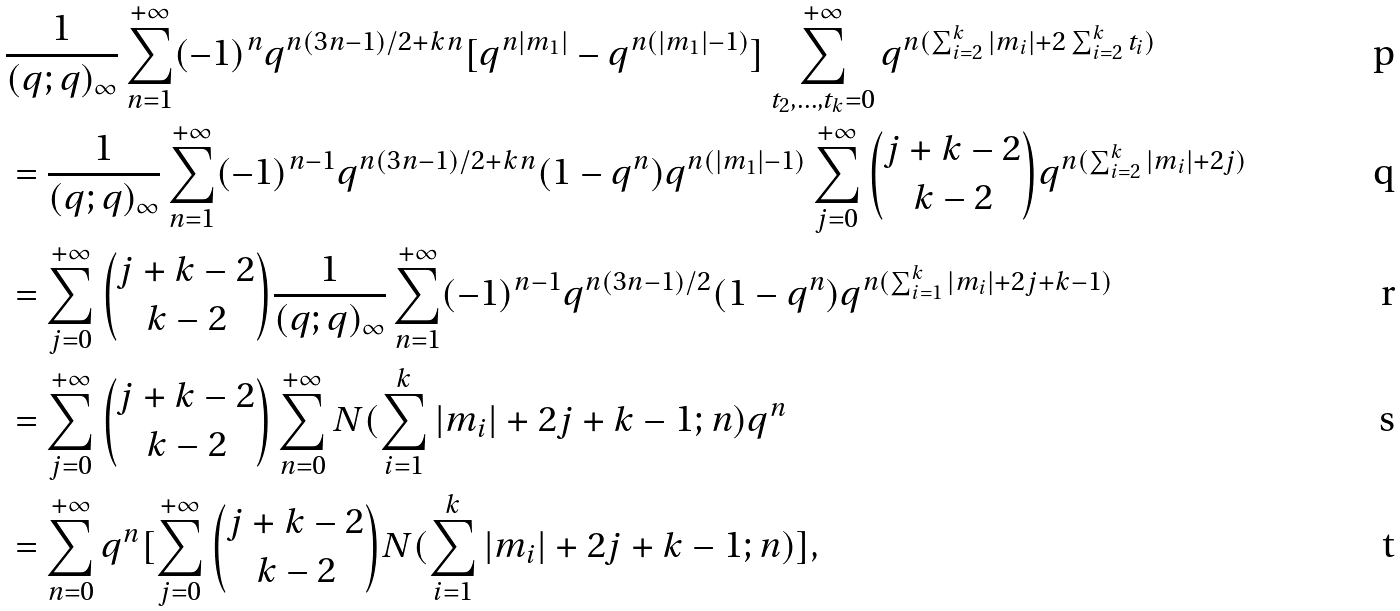<formula> <loc_0><loc_0><loc_500><loc_500>& \frac { 1 } { ( q ; q ) _ { \infty } } \sum _ { n = 1 } ^ { + \infty } ( - 1 ) ^ { n } q ^ { n ( 3 n - 1 ) / 2 + k n } [ q ^ { n | m _ { 1 } | } - q ^ { n ( | m _ { 1 } | - 1 ) } ] \sum _ { t _ { 2 } , \dots , t _ { k } = 0 } ^ { + \infty } q ^ { n ( \sum _ { i = 2 } ^ { k } | m _ { i } | + 2 \sum _ { i = 2 } ^ { k } t _ { i } ) } \\ & = \frac { 1 } { ( q ; q ) _ { \infty } } \sum _ { n = 1 } ^ { + \infty } ( - 1 ) ^ { n - 1 } q ^ { n ( 3 n - 1 ) / 2 + k n } ( 1 - q ^ { n } ) q ^ { n ( | m _ { 1 } | - 1 ) } \sum _ { j = 0 } ^ { + \infty } { j + k - 2 \choose k - 2 } q ^ { n ( \sum _ { i = 2 } ^ { k } | m _ { i } | + 2 j ) } \\ & = \sum _ { j = 0 } ^ { + \infty } { j + k - 2 \choose k - 2 } \frac { 1 } { ( q ; q ) _ { \infty } } \sum _ { n = 1 } ^ { + \infty } ( - 1 ) ^ { n - 1 } q ^ { n ( 3 n - 1 ) / 2 } ( 1 - q ^ { n } ) q ^ { n ( \sum _ { i = 1 } ^ { k } | m _ { i } | + 2 j + k - 1 ) } \\ & = \sum _ { j = 0 } ^ { + \infty } { j + k - 2 \choose k - 2 } \sum _ { n = 0 } ^ { + \infty } N ( \sum _ { i = 1 } ^ { k } | m _ { i } | + 2 j + k - 1 ; n ) q ^ { n } \\ & = \sum _ { n = 0 } ^ { + \infty } q ^ { n } [ \sum _ { j = 0 } ^ { + \infty } { j + k - 2 \choose k - 2 } N ( \sum _ { i = 1 } ^ { k } | m _ { i } | + 2 j + k - 1 ; n ) ] ,</formula> 